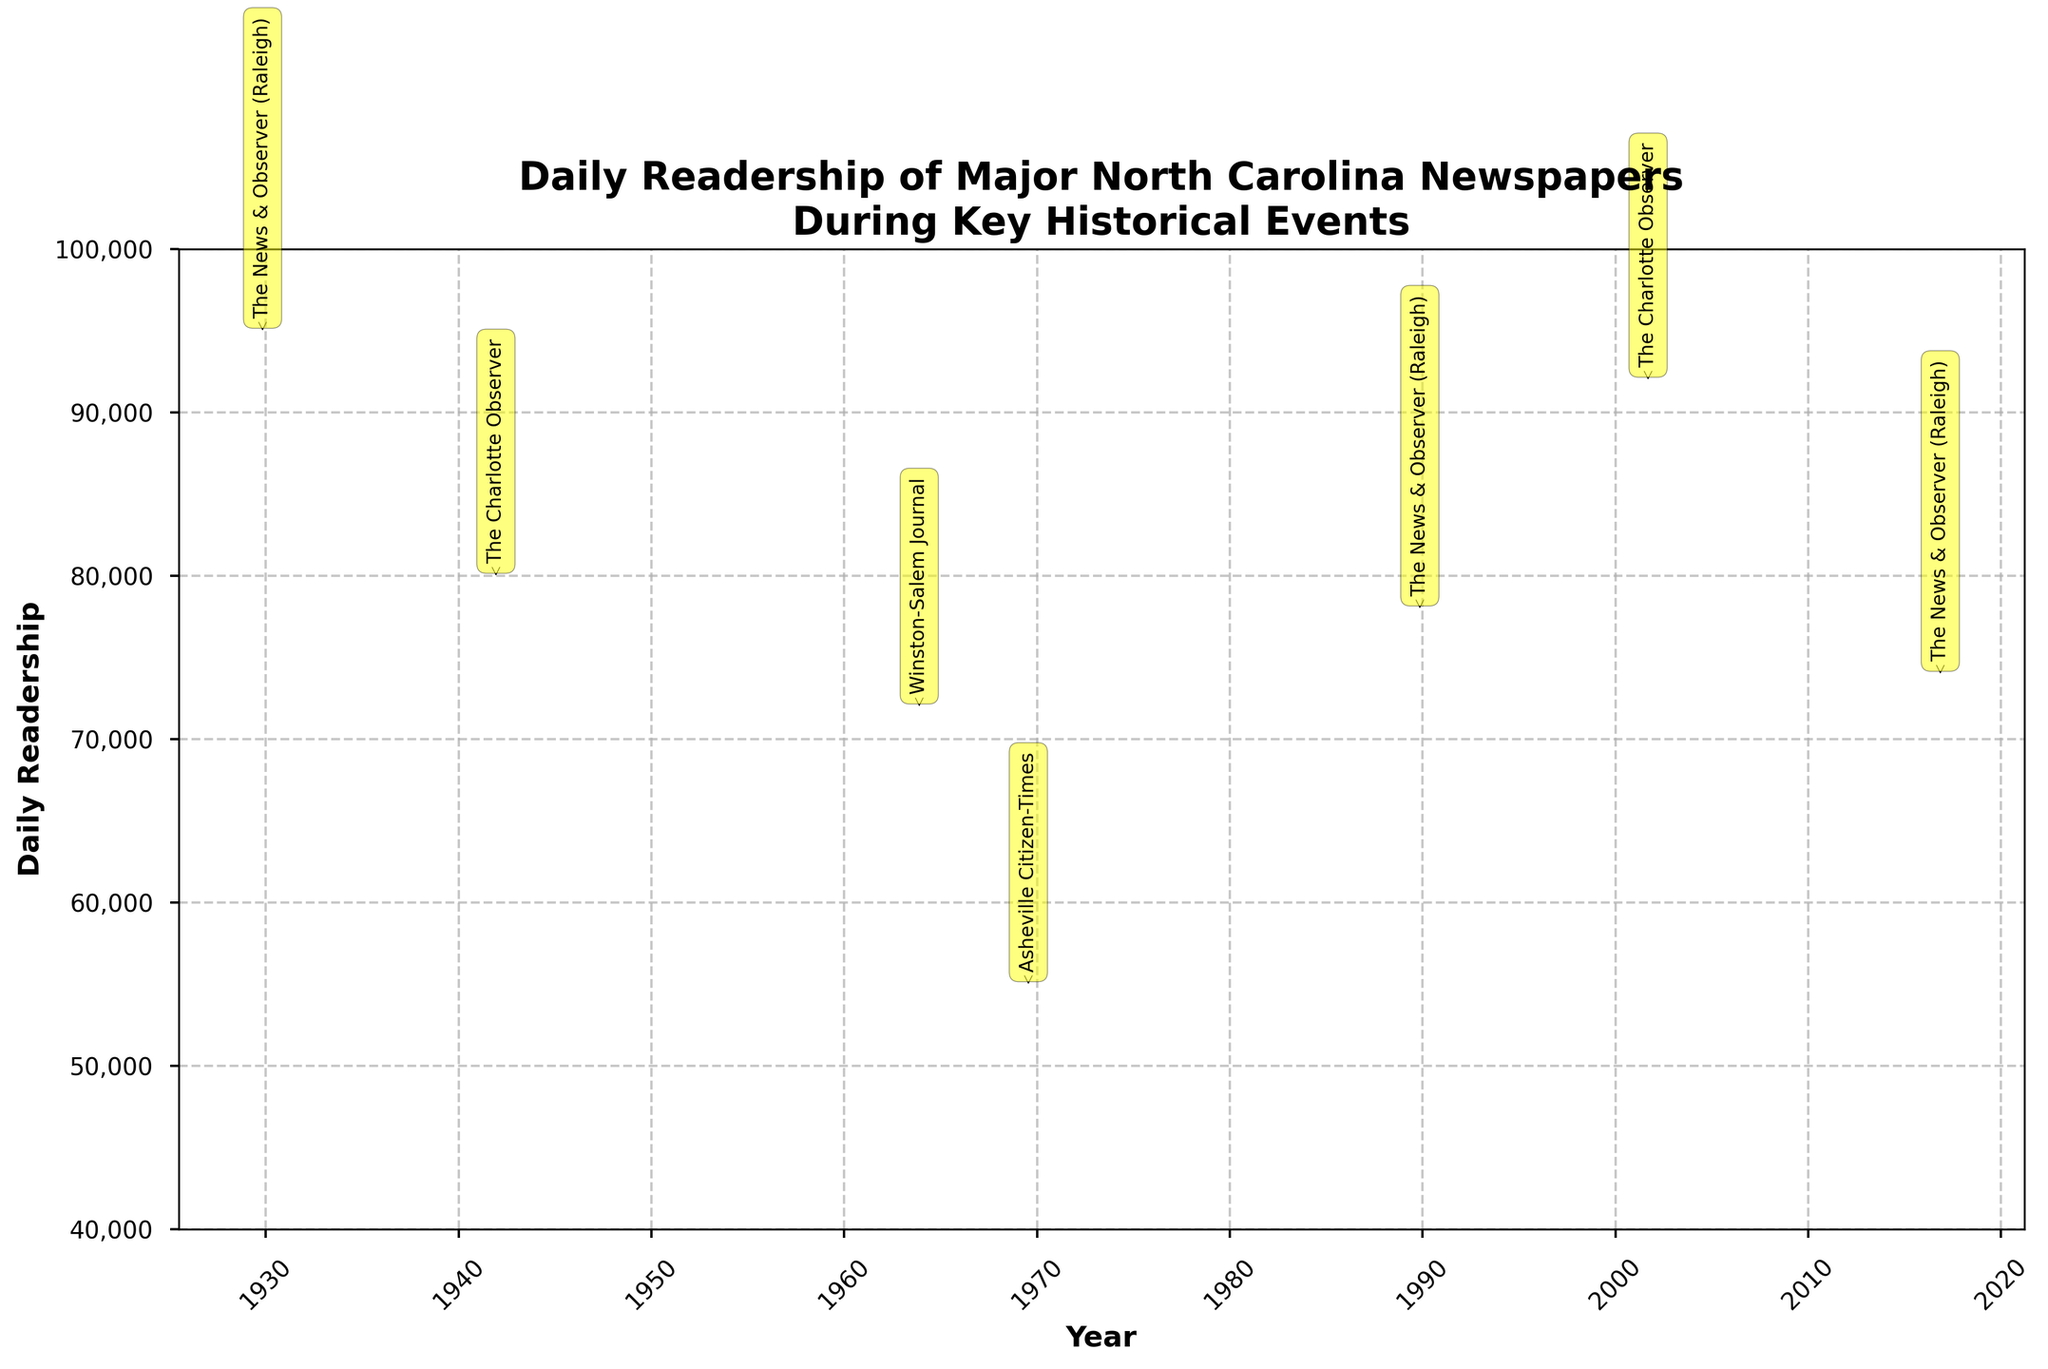What's the title of the plot? The title is located at the top of the plot and is typically the largest text on the figure.
Answer: Daily Readership of Major North Carolina Newspapers During Key Historical Events How many key historical events are represented in the figure? Each candlestick represents one key historical event, and there are seven candlesticks in the figure. Count them to find the number of events.
Answer: 7 Which newspaper had the highest daily readership during the events shown? Look for the highest point in the 'High' readings of the candlesticks. The 'High' of 95,000 for The News & Observer on 1929-10-29 is the highest.
Answer: The News & Observer (Raleigh) What's the average closing readership of "The Charlotte Observer" from the events shown? The closing readership values for "The Charlotte Observer" are 75,000 and 88,000. Add them and divide by 2. (75,000 + 88,000) / 2 = 81,500
Answer: 81,500 Which event showed a decrease in readership compared to the opening value, and by how much did it decrease? Identify the candlesticks where the Close value is less than the Open value. Calculate the difference for each. For instance, The News & Observer on 1929-10-29 dropped from 85,000 to 80,000. 85,000 - 80,000 = 5,000
Answer: The News & Observer (Raleigh) on 1929-10-29, 5,000 decrease What is the range of readership (difference between High and Low) for the event on 2001-09-11? Subtract the Low value from the High value for the specific event. For 2001-09-11: 92,000 - 80,000 = 12,000
Answer: 12,000 Which newspaper showed the smallest variation in readership during its associated event? Calculate the difference between the High and Low values for each event and compare them. The smallest difference is for The Charlotte Observer on 1941-12-07 (80,000 - 70,000 = 10,000).
Answer: The Charlotte Observer on 1941-12-07 What were the highest and lowest readership values for The News & Observer across all events shown? Look at all candlesticks representing The News & Observer and check their High and Low values. The highest is 95,000, and the lowest is 65,000.
Answer: High: 95,000, Low: 65,000 During which event did the Winston-Salem Journal have a readership that closed lower than it opened? Identify the candlestick for Winston-Salem Journal. For 1963-11-22, it shows a Close value lower than its Open value (68,000 < 65,000).
Answer: 1963-11-22 What is the median opening readership of all the newspapers during the events shown? First, list the Open values: 85,000, 75,000, 65,000, 50,000, 72,000, 85,000, 67,000. Sort them: 50,000, 65,000, 67,000, 72,000, 75,000, 85,000, 85,000. The median is the middle value, which is 72,000.
Answer: 72,000 